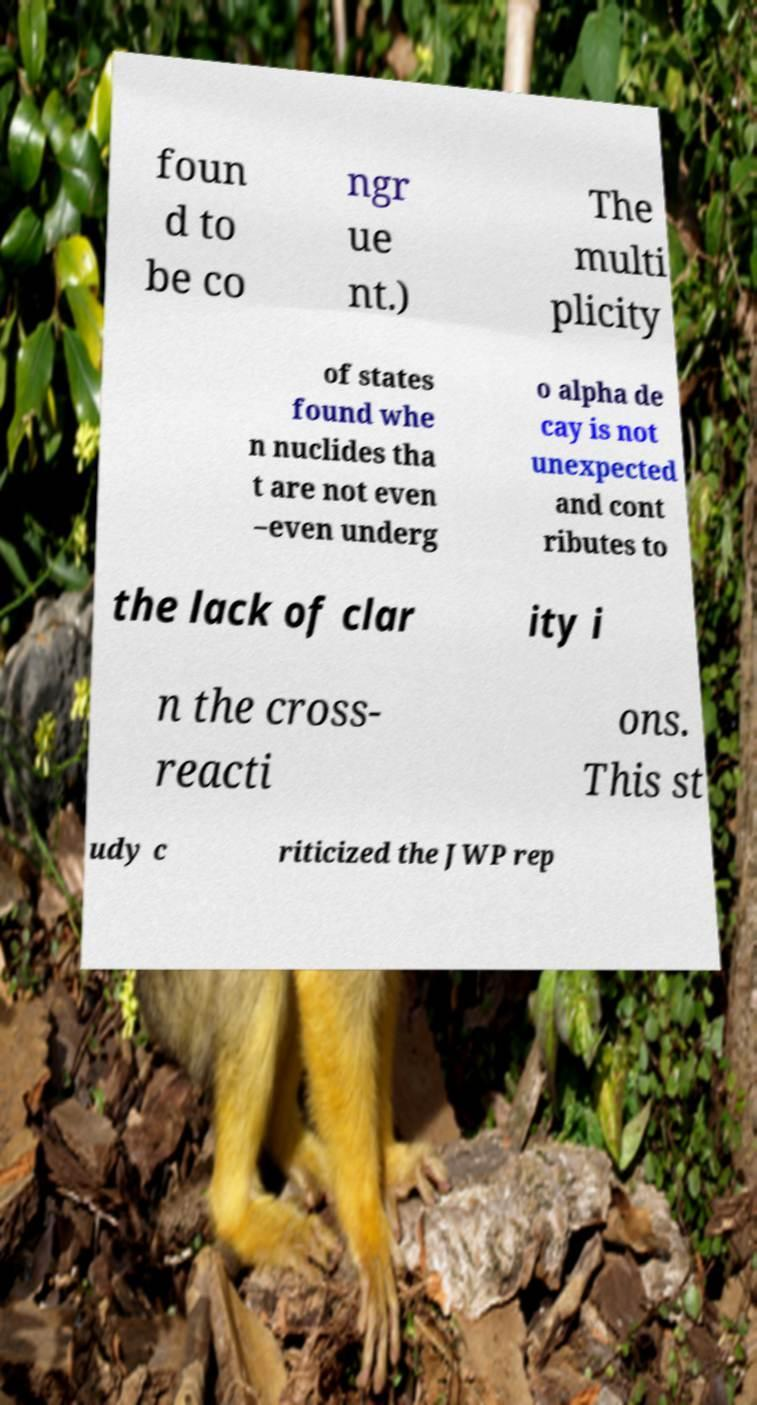I need the written content from this picture converted into text. Can you do that? foun d to be co ngr ue nt.) The multi plicity of states found whe n nuclides tha t are not even –even underg o alpha de cay is not unexpected and cont ributes to the lack of clar ity i n the cross- reacti ons. This st udy c riticized the JWP rep 